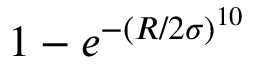Convert formula to latex. <formula><loc_0><loc_0><loc_500><loc_500>1 - e ^ { - ( R / 2 \sigma ) ^ { 1 0 } }</formula> 